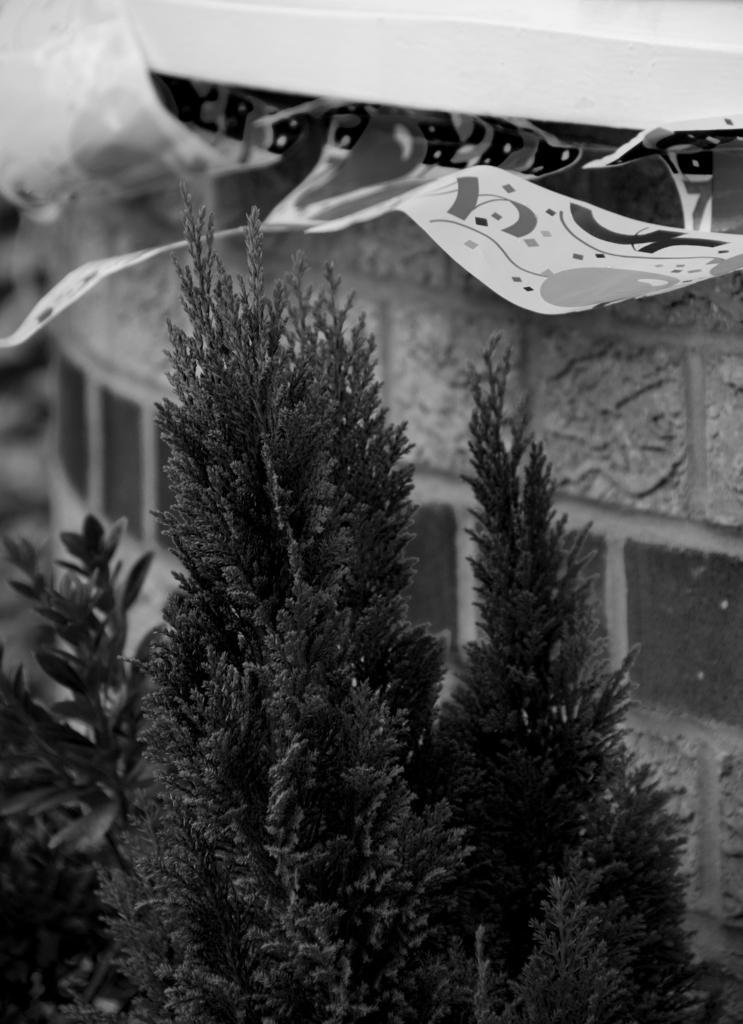How would you summarize this image in a sentence or two? In this picture we can see few plants and it is a black and white photography. 